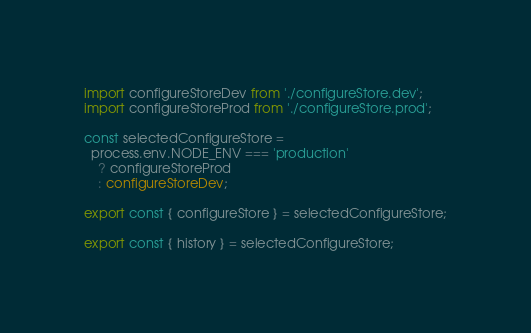Convert code to text. <code><loc_0><loc_0><loc_500><loc_500><_TypeScript_>
import configureStoreDev from './configureStore.dev';
import configureStoreProd from './configureStore.prod';

const selectedConfigureStore =
  process.env.NODE_ENV === 'production'
    ? configureStoreProd
    : configureStoreDev;

export const { configureStore } = selectedConfigureStore;

export const { history } = selectedConfigureStore;
</code> 